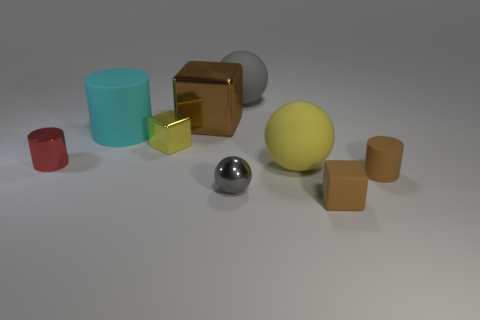The red cylinder has what size?
Offer a terse response. Small. What number of red objects are either metallic cylinders or tiny cylinders?
Offer a terse response. 1. There is a object to the right of the tiny brown rubber thing in front of the small rubber cylinder; what size is it?
Offer a very short reply. Small. Does the large metal block have the same color as the cylinder that is on the right side of the tiny gray shiny sphere?
Your answer should be very brief. Yes. How many other objects are there of the same material as the small red cylinder?
Your answer should be very brief. 3. The small gray object that is made of the same material as the tiny yellow object is what shape?
Offer a very short reply. Sphere. Is there anything else that has the same color as the matte cube?
Provide a short and direct response. Yes. What size is the rubber object that is the same color as the small matte block?
Your answer should be compact. Small. Are there more big cubes that are right of the gray metallic thing than tiny brown things?
Your answer should be very brief. No. There is a cyan object; is its shape the same as the brown thing that is right of the small brown rubber cube?
Provide a succinct answer. Yes. 